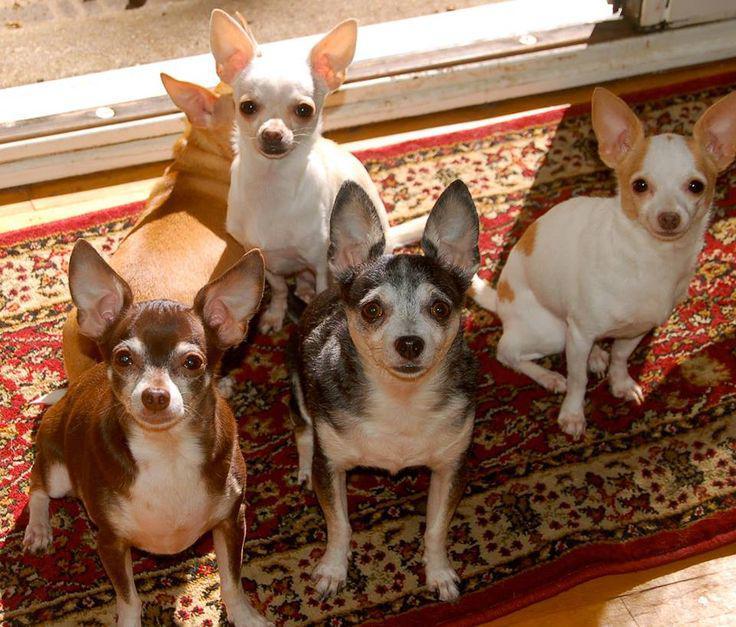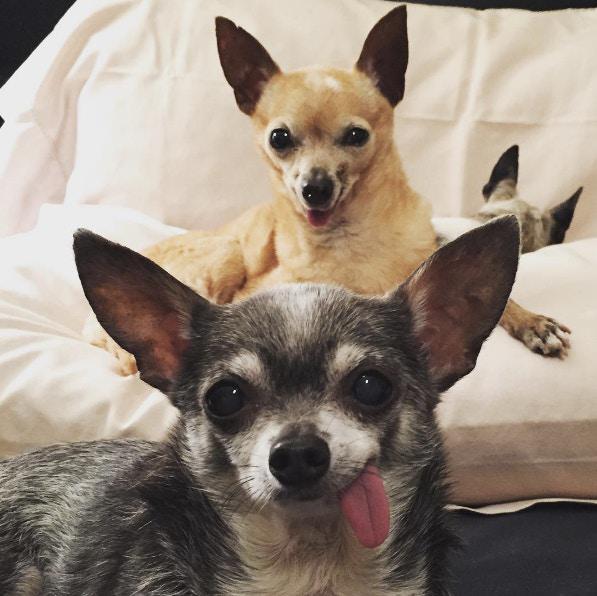The first image is the image on the left, the second image is the image on the right. For the images displayed, is the sentence "There are four dogs in one image and the other has only one." factually correct? Answer yes or no. No. The first image is the image on the left, the second image is the image on the right. Analyze the images presented: Is the assertion "One image shows one tan dog wearing a collar, and the other image includes at least one chihuahua wearing something hot pink." valid? Answer yes or no. No. 